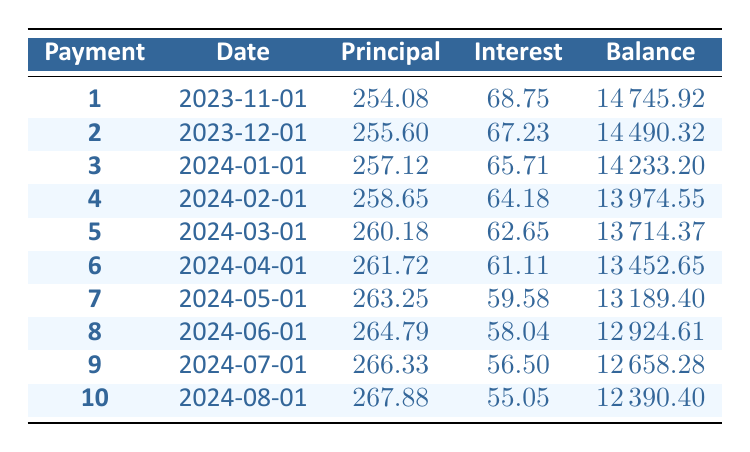What is the monthly payment for this loan? The monthly payment is explicitly stated in the loan details section of the table. It shows that the monthly payment is 287.08.
Answer: 287.08 What is the principal payment in the first month? The first month's principal payment can be found in the amortization schedule under the "Principal" column for payment number 1. It shows 254.08.
Answer: 254.08 How much total interest will be paid over the term of the loan? The total interest paid can be identified in the loan details section of the table, which indicates a total interest of 2224.80 over the entire loan term.
Answer: 2224.80 Is the remaining balance decreasing with each payment? To determine if the remaining balance decreases, we can observe the "Balance" column across the payments. Since every payment amount reduces the outstanding balance, it is clear that the remaining balance is consistently decreasing after each payment.
Answer: Yes What is the difference between the principal payment of the first month and the last month? First, we take the principal payment for the first month, which is 254.08, and subtract the principal payment of the last month (the 10th month is 267.88) from it: 267.88 - 254.08 = 13.80.
Answer: 13.80 How much interest is paid in the second month? The interest payment for the second month is listed in the amortization schedule under the "Interest" column for payment number 2, which shows an amount of 67.23.
Answer: 67.23 What is the total principal paid after the first five payments? We add the principal payments from the first five months: 254.08 + 255.60 + 257.12 + 258.65 + 260.18 = 1285.63.
Answer: 1285.63 Which month has the highest principal payment and what is that value? We can glance through the principal payments for each month in the table. The highest principal payment occurs in the last month (10th payment) at 267.88.
Answer: 267.88 What is the remaining balance after the third payment? The remaining balance after the third payment can be found in the amortization schedule under the "Balance" column for payment number 3, which shows 14233.20.
Answer: 14233.20 